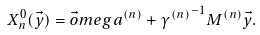Convert formula to latex. <formula><loc_0><loc_0><loc_500><loc_500>X ^ { 0 } _ { n } ( \vec { y } ) = \vec { o } m e g a ^ { ( n ) } + { \gamma ^ { ( n ) } } ^ { - 1 } M ^ { ( n ) } \vec { y } .</formula> 